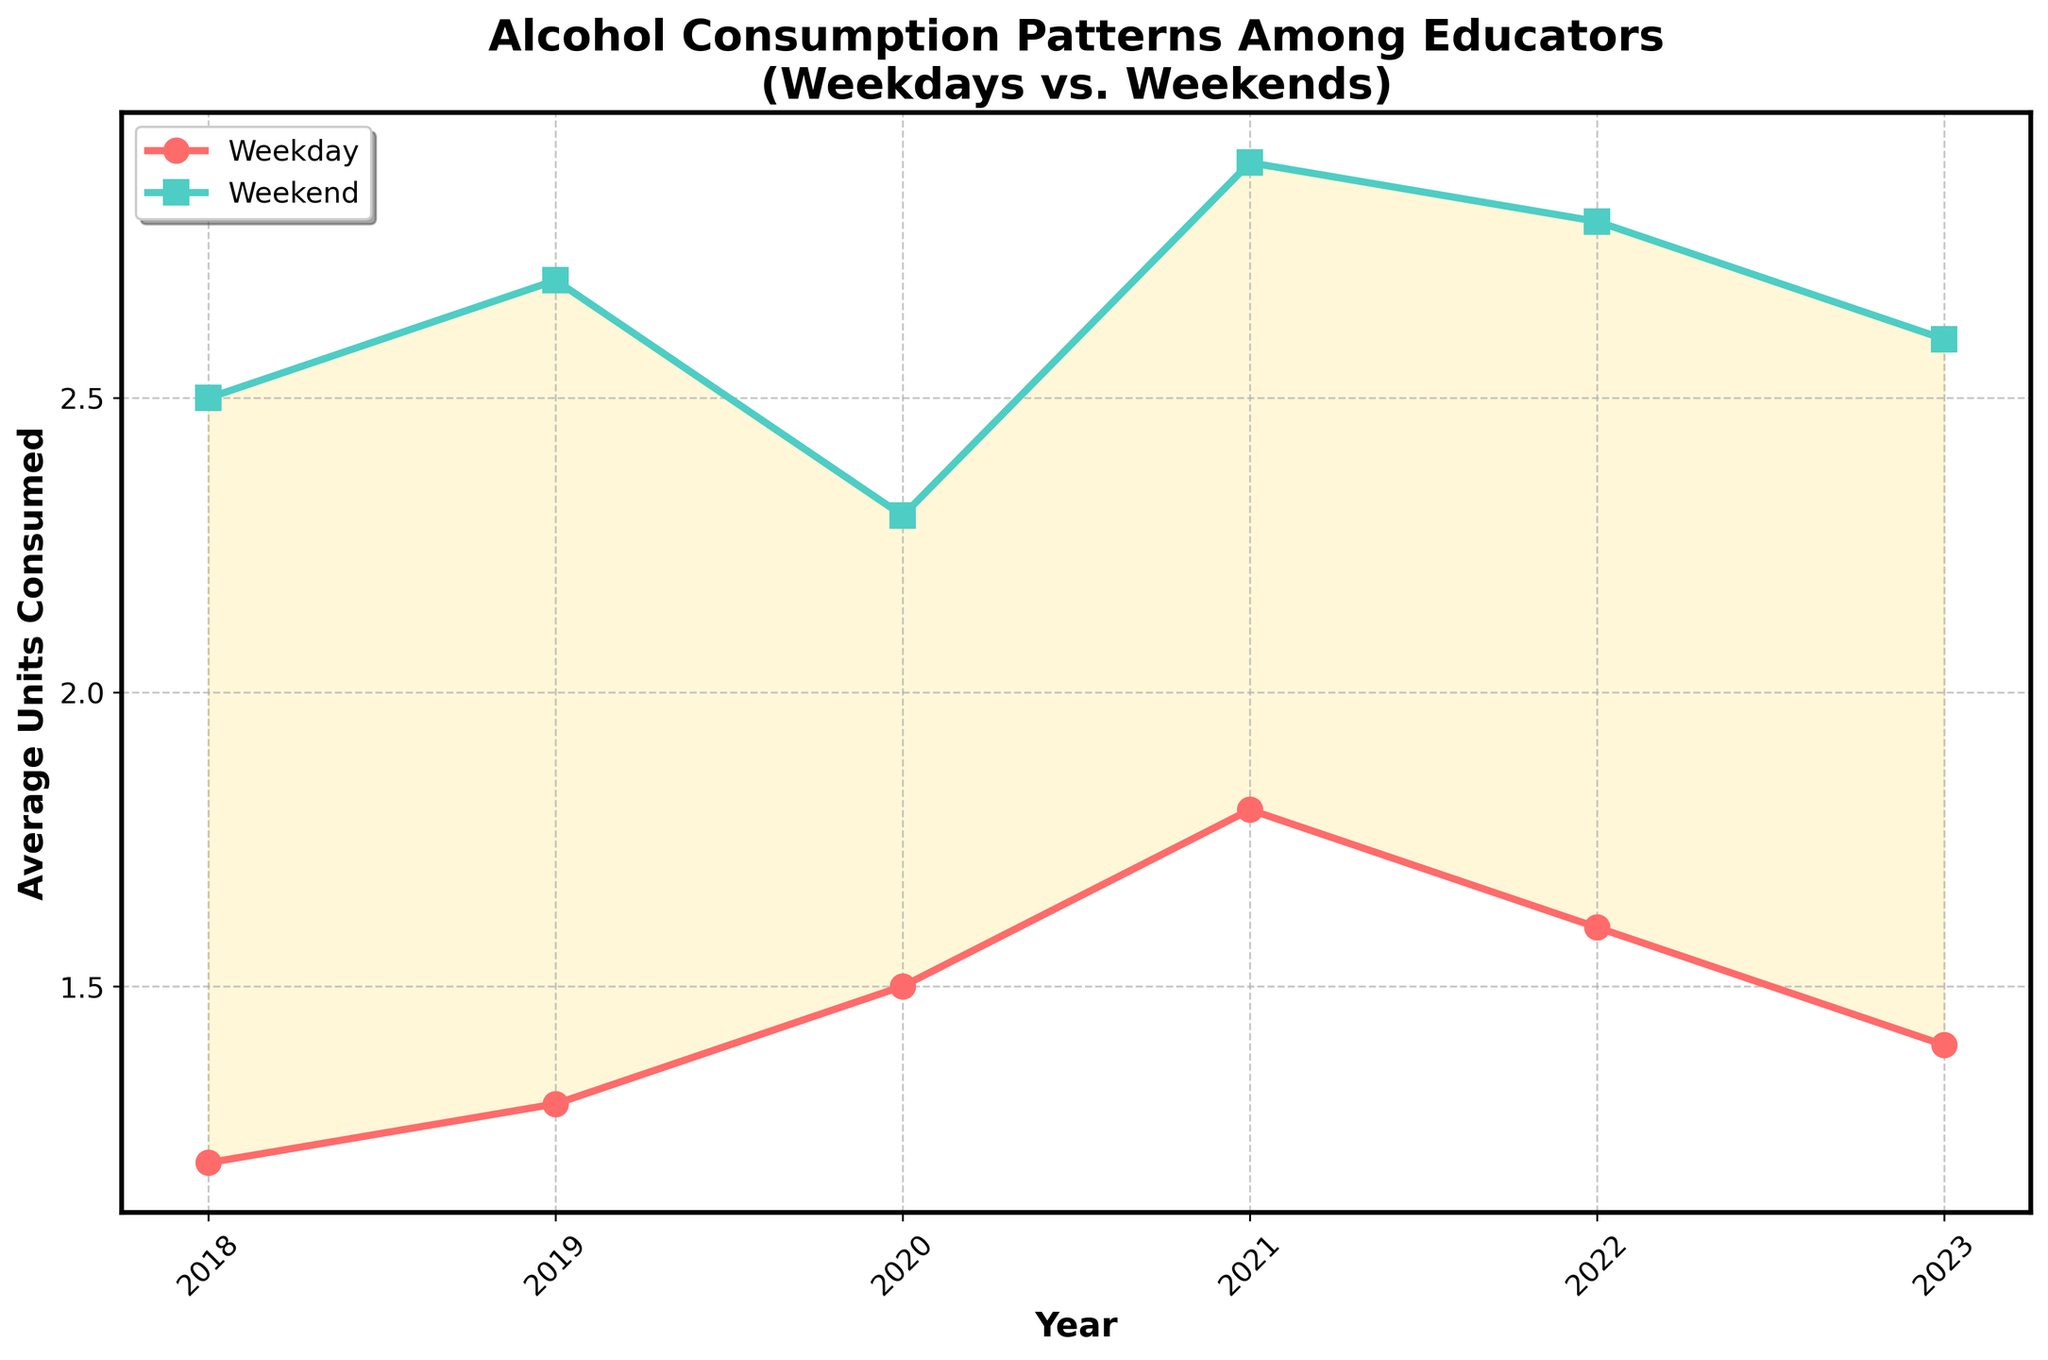What was the average units consumed during weekdays and weekends in 2021? The figure shows the data for each year. For 2021, the average units consumed on weekdays is 1.8, and on weekends it is 2.9.
Answer: Weekday: 1.8, Weekend: 2.9 Was there any year when weekend consumption was equal to or less than weekday consumption? By looking at the plot, we see that for every year, weekend consumption is higher than weekday consumption. No year shows equal or lesser consumption for weekends compared to weekdays.
Answer: No Which year showed the highest average unit of alcohol consumed on weekdays? From the plot, we can see the highest point for weekday consumption. That occurs in 2021 with a value of 1.8 average units consumed.
Answer: 2021 Is the trend of alcohol consumption on weekdays increasing or decreasing over the 5 years? Observing the line for weekdays, the values from 2018 to 2023 are 1.2, 1.3, 1.5, 1.8, 1.6, and 1.4. Initially, it increases, peaks in 2021, and then starts to decrease towards 2023.
Answer: Increasing initially, then decreasing How does the difference between weekend and weekday consumption in 2019 compare to 2023? In 2019, the difference between weekend and weekday consumption is 2.7 - 1.3 = 1.4. In 2023, the difference is 2.6 - 1.4 = 1.2. Hence, the difference decreases from 2019 to 2023.
Answer: 2019: 1.4, 2023: 1.2 Which year had the least difference in consumption between weekdays and weekends? The differences for each year are computed as follows:
2018: 2.5 - 1.2 = 1.3
2019: 2.7 - 1.3 = 1.4
2020: 2.3 - 1.5 = 0.8
2021: 2.9 - 1.8 = 1.1
2022: 2.8 - 1.6 = 1.2
2023: 2.6 - 1.4 = 1.2
The smallest difference is in 2020, which is 0.8.
Answer: 2020 Is there a year where average weekday consumption is higher than the value in 2023? The plot shows weekday values over the years. For 2023, the average is 1.4. Both 2021 and 2022 have higher values, at 1.8 and 1.6 respectively.
Answer: Yes, 2021 and 2022 What trend do we observe in weekend alcohol consumption from 2018 to 2023? By following the weekend line, we can see that the values change as follows: 2.5, 2.7, 2.3, 2.9, 2.8, and 2.6. Overall, the trend peaks in 2021 and slightly decreases thereafter.
Answer: Increasing, then slightly decreasing 